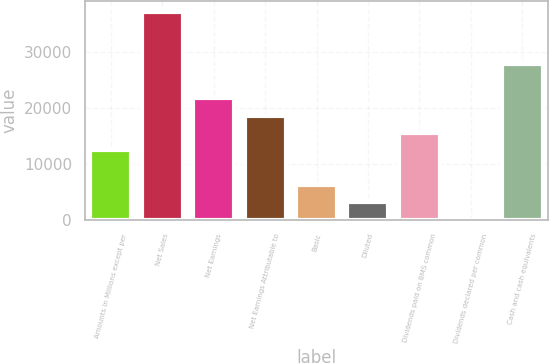<chart> <loc_0><loc_0><loc_500><loc_500><bar_chart><fcel>Amounts in Millions except per<fcel>Net Sales<fcel>Net Earnings<fcel>Net Earnings Attributable to<fcel>Basic<fcel>Diluted<fcel>Dividends paid on BMS common<fcel>Dividends declared per common<fcel>Cash and cash equivalents<nl><fcel>12431.2<fcel>37290.9<fcel>21753.6<fcel>18646.1<fcel>6216.23<fcel>3108.76<fcel>15538.6<fcel>1.29<fcel>27968.5<nl></chart> 